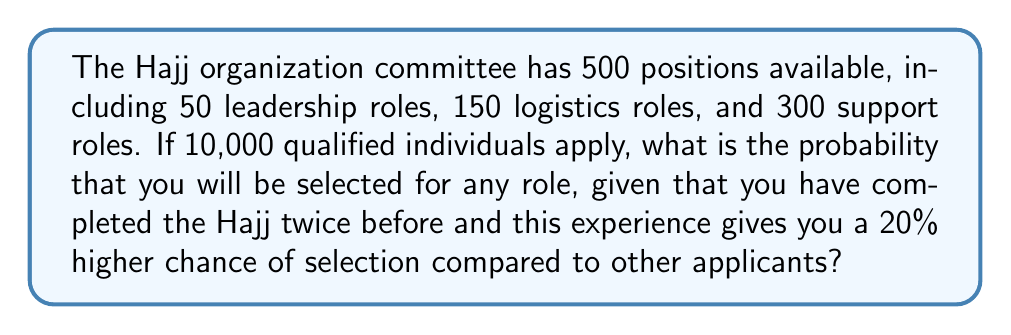Show me your answer to this math problem. Let's approach this step-by-step:

1) First, let's calculate the base probability of being selected without considering your experience:

   $P(\text{base selection}) = \frac{\text{Total positions}}{\text{Total applicants}} = \frac{500}{10,000} = 0.05 = 5\%$

2) Now, we need to factor in your increased chance due to your Hajj experience. Your probability is 20% higher than the base probability:

   $P(\text{your selection}) = P(\text{base selection}) \times 1.20$
   
   $P(\text{your selection}) = 0.05 \times 1.20 = 0.06 = 6\%$

3) To understand this in the context of all applicants, let's calculate how many "effective applicants" there are when considering your advantage:

   $\text{Effective applicants} = 9,999 + 1.20 = 10,000.20$

4) Your probability can also be calculated as:

   $P(\text{your selection}) = \frac{1.20}{10,000.20} = 0.00011998 \approx 0.06\%$

5) This confirms our earlier calculation and shows that while your chances are improved, the competition is still fierce due to the large number of applicants.
Answer: $6\%$ or $0.06$ 